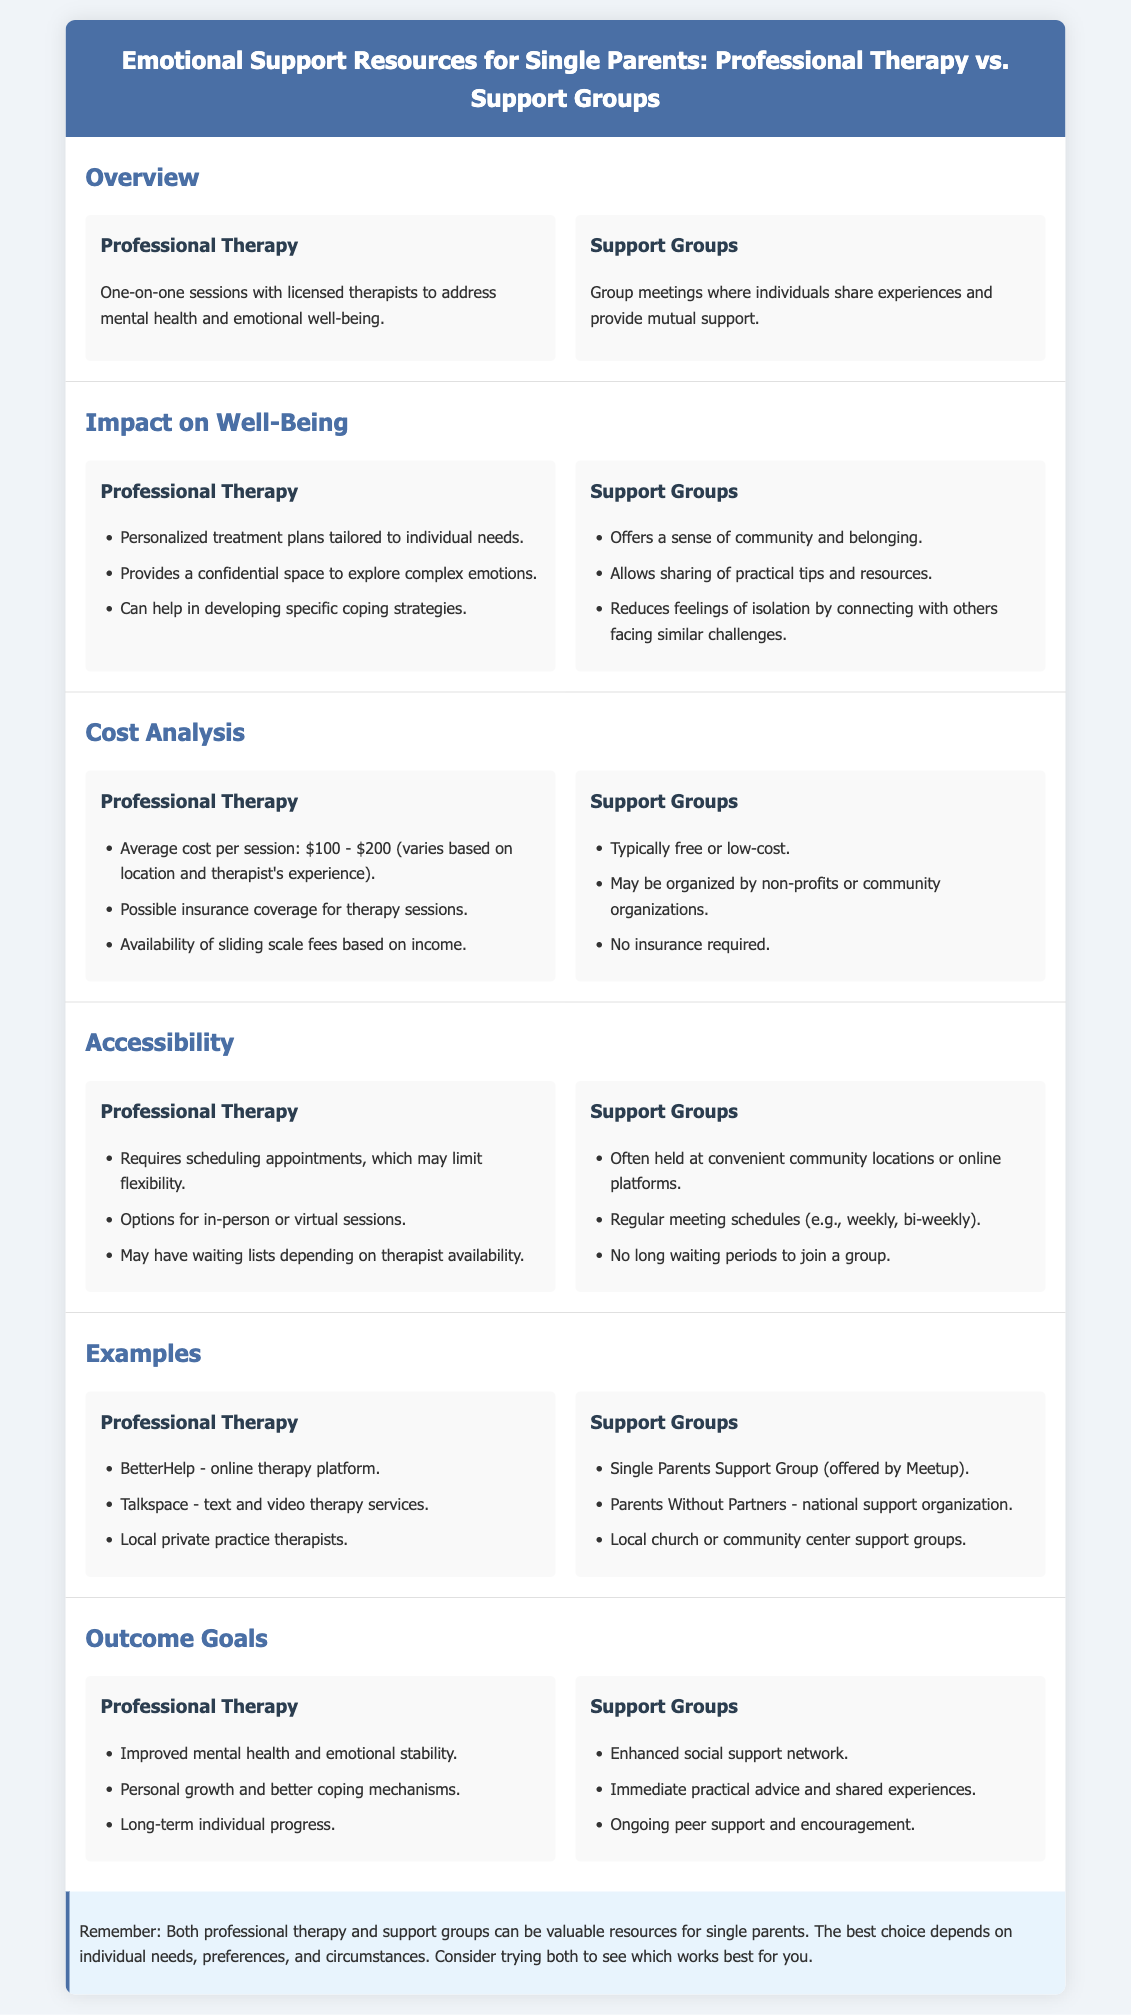What is the average cost per session for professional therapy? The document states that the average cost per session ranges between $100 - $200.
Answer: $100 - $200 Which therapy platform is mentioned as providing online services? The document lists BetterHelp as an example of an online therapy platform.
Answer: BetterHelp What is one benefit of support groups mentioned in the infographic? The infographic states that support groups offer a sense of community and belonging.
Answer: Sense of community What flexibility does professional therapy require? The document mentions that professional therapy requires scheduling appointments, which may limit flexibility.
Answer: Scheduling appointments How do support groups typically compare in cost to professional therapy? The document indicates that support groups are typically free or low-cost compared to professional therapy.
Answer: Free or low-cost What is a common outcome goal of support groups? The document states that one goal is enhanced social support network.
Answer: Enhanced social support network What type of meeting schedule is mentioned for support groups? The document indicates that support groups have regular meeting schedules (e.g., weekly, bi-weekly).
Answer: Regular meeting schedules What is a personalized benefit of professional therapy? The document highlights that professional therapy provides personalized treatment plans tailored to individual needs.
Answer: Personalized treatment plans What kind of therapeutic sessions can professional therapy provide? The document states that professional therapy offers one-on-one sessions with licensed therapists.
Answer: One-on-one sessions 